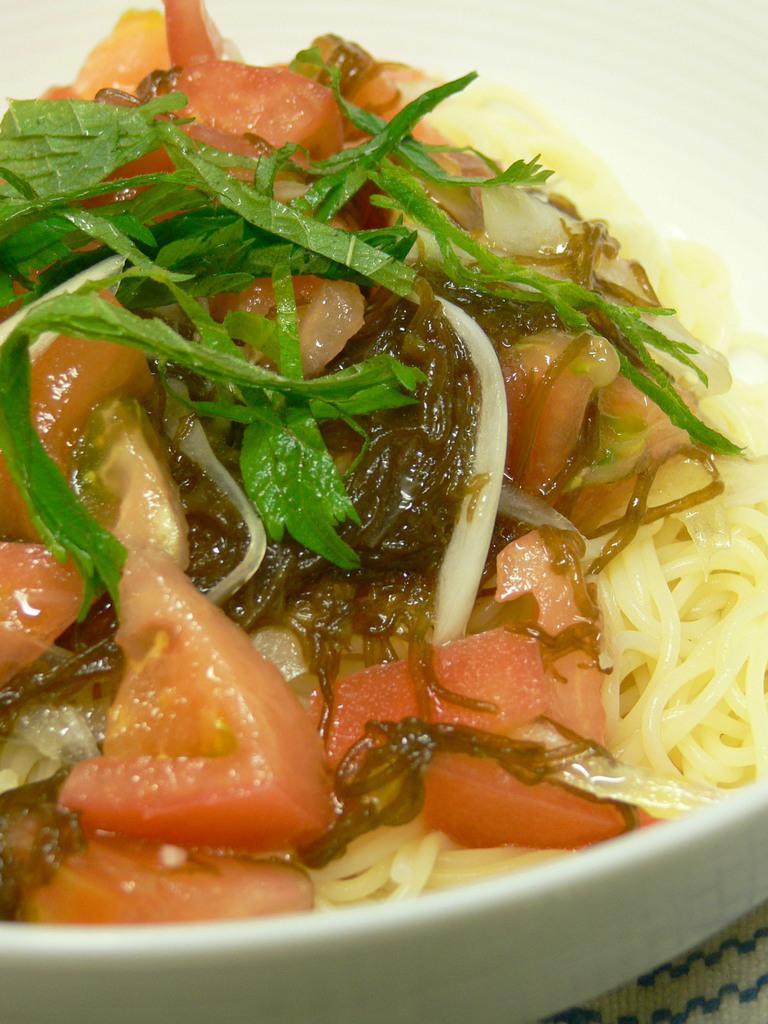Please provide a concise description of this image. In this image we can see a food in a bowl. The food is garnished with the green leaves. 